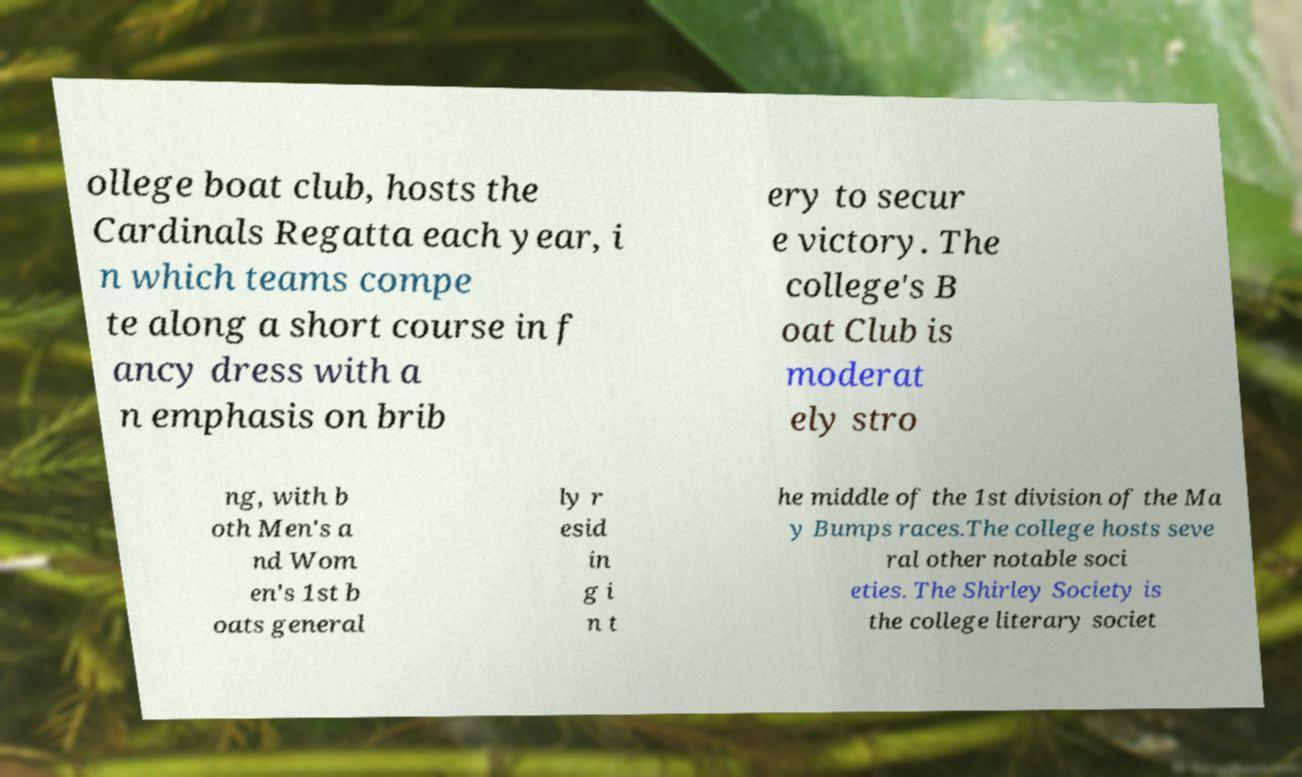Could you extract and type out the text from this image? ollege boat club, hosts the Cardinals Regatta each year, i n which teams compe te along a short course in f ancy dress with a n emphasis on brib ery to secur e victory. The college's B oat Club is moderat ely stro ng, with b oth Men's a nd Wom en's 1st b oats general ly r esid in g i n t he middle of the 1st division of the Ma y Bumps races.The college hosts seve ral other notable soci eties. The Shirley Society is the college literary societ 